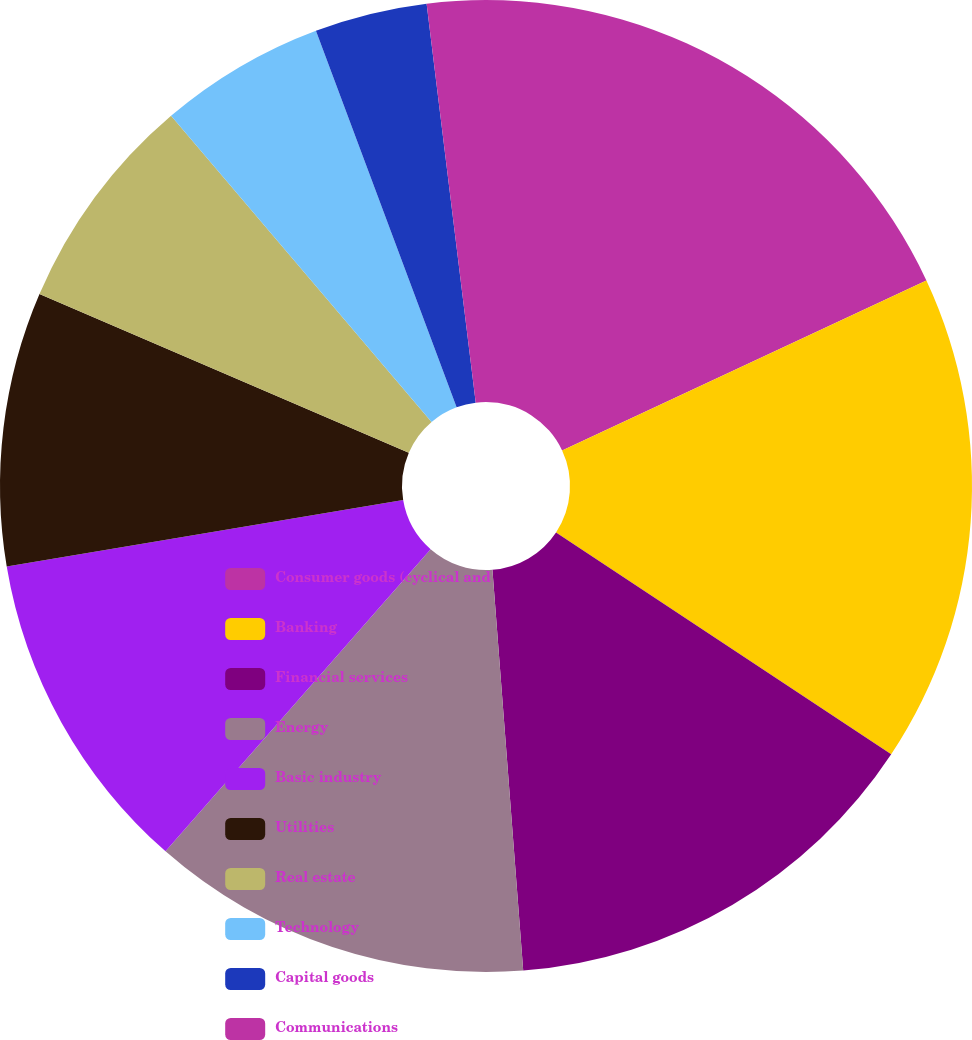Convert chart to OTSL. <chart><loc_0><loc_0><loc_500><loc_500><pie_chart><fcel>Consumer goods (cyclical and<fcel>Banking<fcel>Financial services<fcel>Energy<fcel>Basic industry<fcel>Utilities<fcel>Real estate<fcel>Technology<fcel>Capital goods<fcel>Communications<nl><fcel>18.05%<fcel>16.26%<fcel>14.47%<fcel>12.68%<fcel>10.89%<fcel>9.11%<fcel>7.32%<fcel>5.53%<fcel>3.74%<fcel>1.95%<nl></chart> 